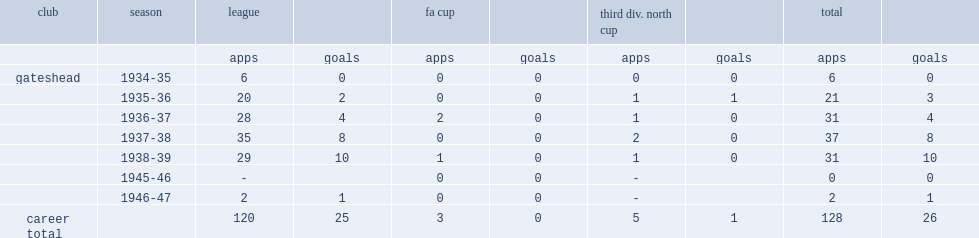How many goals did oxley score for gatehead totally? 26.0. 